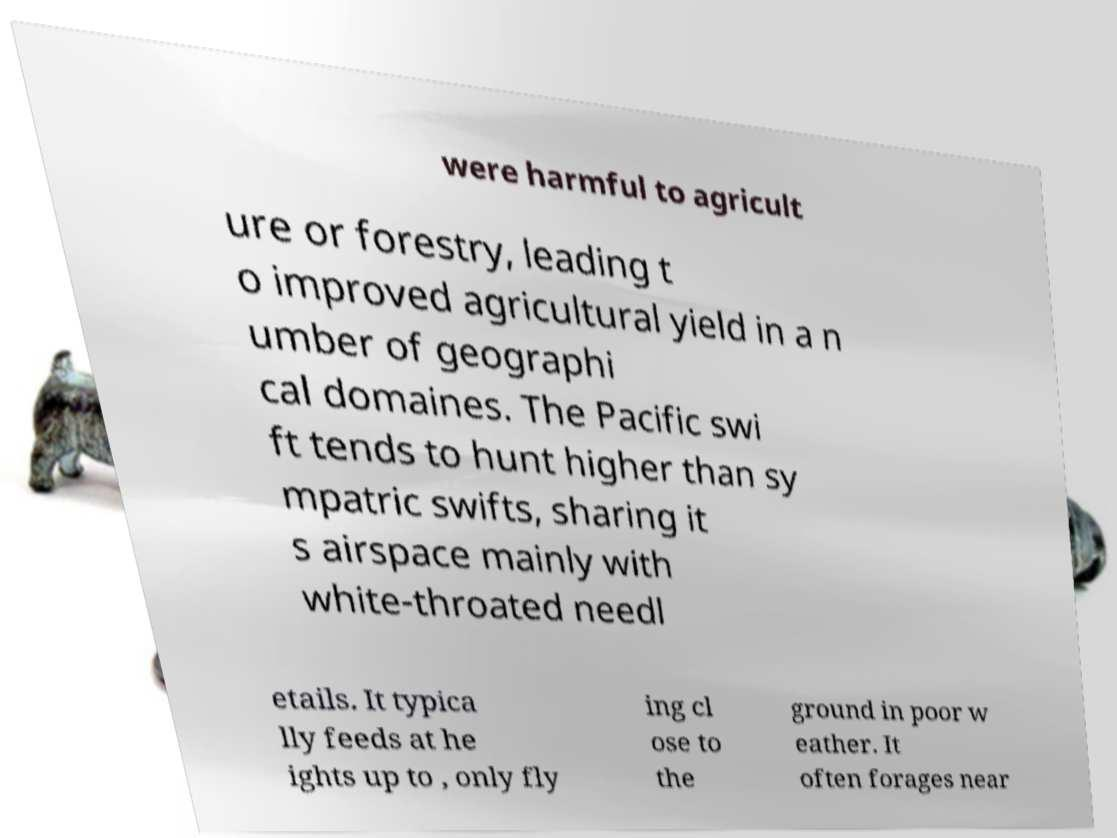What messages or text are displayed in this image? I need them in a readable, typed format. were harmful to agricult ure or forestry, leading t o improved agricultural yield in a n umber of geographi cal domaines. The Pacific swi ft tends to hunt higher than sy mpatric swifts, sharing it s airspace mainly with white-throated needl etails. It typica lly feeds at he ights up to , only fly ing cl ose to the ground in poor w eather. It often forages near 